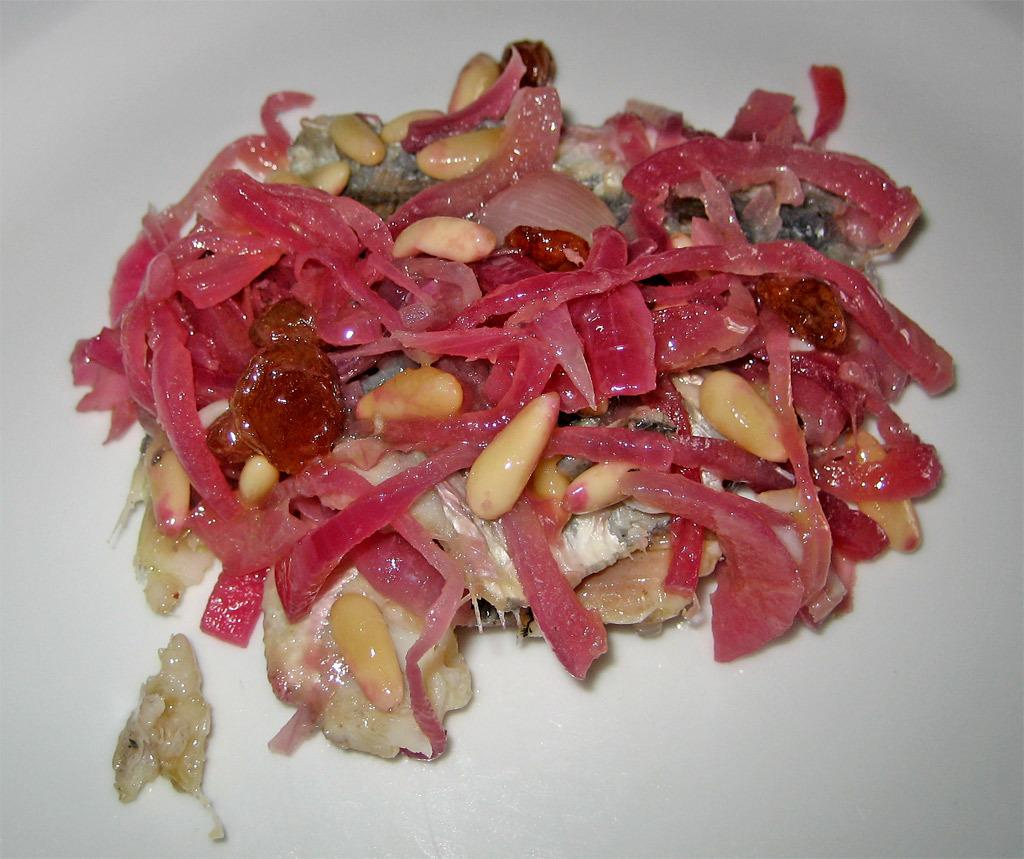What is the main subject of the image? There is a food item in the image. What type of club can be seen in the image? There is no club present in the image; it only features a food item. Is there a stick visible in the front of the image? There is no stick mentioned in the provided fact, and therefore we cannot determine if one is present or not. 